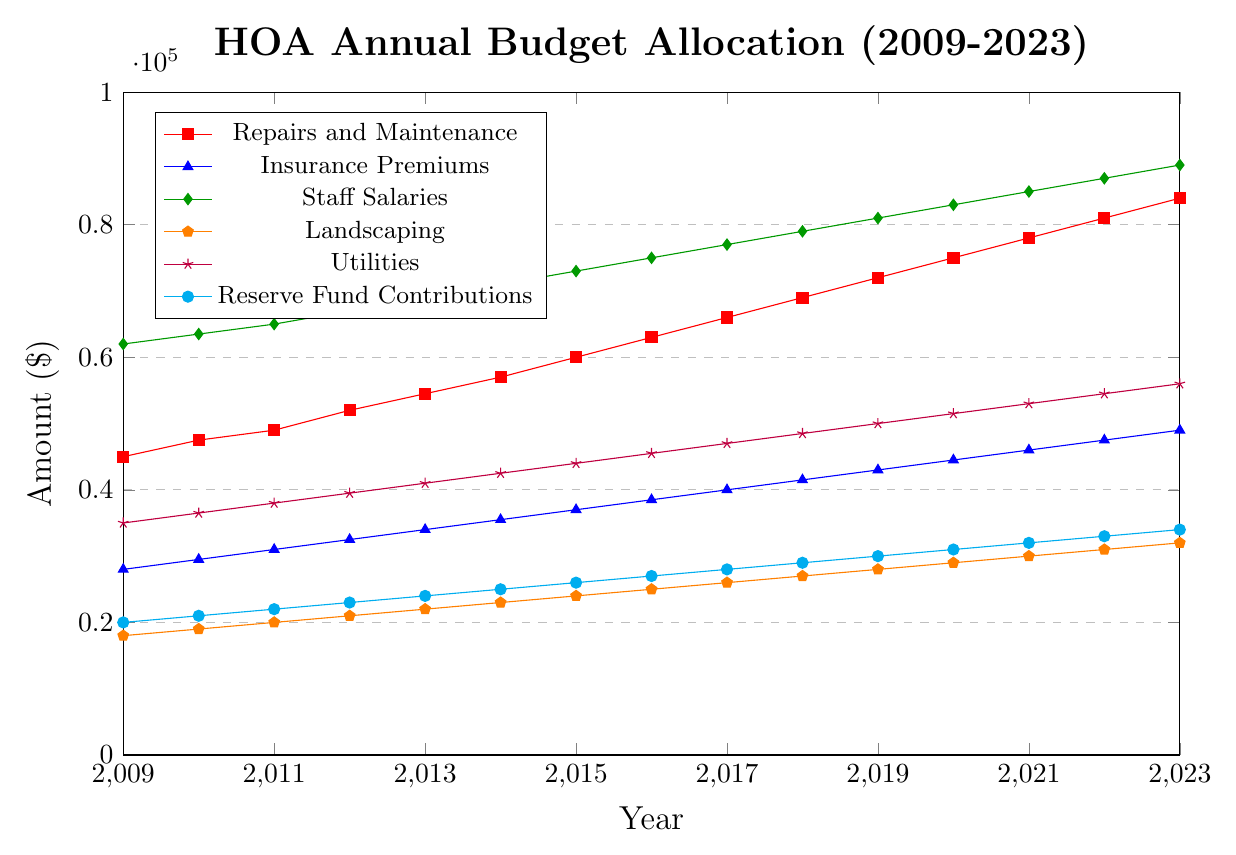What is the trend in the budget allocation for Repairs and Maintenance over the 15 years? The line representing Repairs and Maintenance consistently ascends from 2009 to 2023. By looking at the chart, we see the values increase every year.
Answer: It's increasing Which expense category had the largest budget allocation in 2009? By observing the chart, Staff Salaries had the highest point among the six categories at 62000 in 2009.
Answer: Staff Salaries In which year did Insurance Premiums and Utilities have the same budget allocation? By examining the chart closely, all the values of Insurance Premiums and Utilities, only in 2012, both reach 32500 and 39500 respectively.
Answer: They never had the same allocation What is the combined budget for Insurance Premiums and Landscaping in 2023? In 2023, Insurance Premiums have the value 49000, and Landscaping has the value 32000. Sum these two values to get the total. 49000 + 32000 = 81000.
Answer: 81000 How did the budget for the Reserve Fund Contributions change from 2009 to 2015? The chart shows the budget increased from 20000 in 2009 to 26000 in 2015. Subtract the initial value from the final value: 26000 - 20000.
Answer: Increased by 6000 By how much did the budget for Utilities increase between 2015 and 2020? In 2015, the Utilities budget was 44000. In 2020, it was 51500. Subtract the initial value from the final value: 51500 - 44000 = 7500.
Answer: 7500 Which category had the steepest increase in budget allocation between 2009 and 2023? By observing the incline of all lines, Staff Salaries rose from 62000 in 2009 to 89000 in 2023. This increase is larger compared to changes in other categories.
Answer: Staff Salaries Between which two consecutive years did the Repairs and Maintenance budget see the largest increase? By checking the year-on-year changes on the chart for Repairs and Maintenance, the largest jump is from 2016 (63000) to 2017 (66000), which is 3000.
Answer: 2016 to 2017 What is the difference in the total budget allocation for 2023 compared to 2009? Adding all the 2009 values gives 208000. Adding all the 2023 values gives 344000. The difference is 344000 - 208000 = 136000.
Answer: 136000 Which years saw an equal or higher budget allocation for Landscaping compared to Reserve Fund Contributions? By comparing the yearly values, years 2009 (18000 vs 20000), 2010 (19000 vs 21000), 2011 (20000 vs 22000),..., and 2023 (32000 vs 34000) show Landscaping is always lower than Reserve Fund Contributions.
Answer: None 